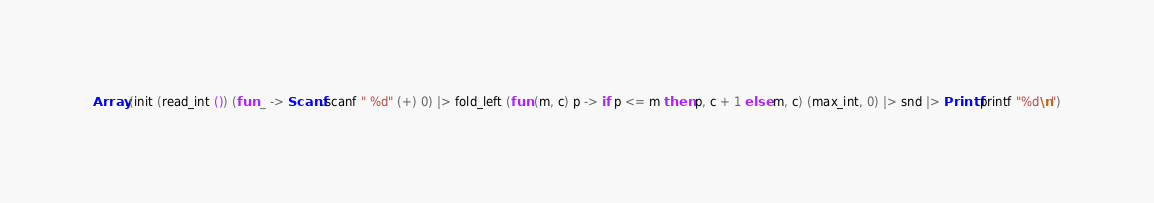<code> <loc_0><loc_0><loc_500><loc_500><_OCaml_>Array.(init (read_int ()) (fun _ -> Scanf.scanf " %d" (+) 0) |> fold_left (fun (m, c) p -> if p <= m then p, c + 1 else m, c) (max_int, 0) |> snd |> Printf.printf "%d\n")</code> 